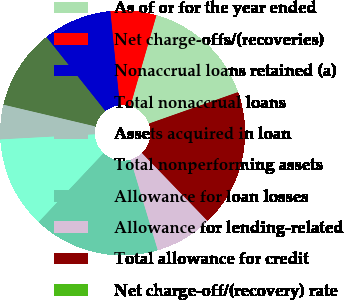Convert chart to OTSL. <chart><loc_0><loc_0><loc_500><loc_500><pie_chart><fcel>As of or for the year ended<fcel>Net charge-offs/(recoveries)<fcel>Nonaccrual loans retained (a)<fcel>Total nonaccrual loans<fcel>Assets acquired in loan<fcel>Total nonperforming assets<fcel>Allowance for loan losses<fcel>Allowance for lending-related<fcel>Total allowance for credit<fcel>Net charge-off/(recovery) rate<nl><fcel>15.15%<fcel>6.06%<fcel>9.09%<fcel>10.61%<fcel>4.55%<fcel>12.12%<fcel>16.67%<fcel>7.58%<fcel>18.18%<fcel>0.0%<nl></chart> 